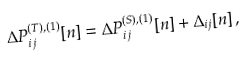<formula> <loc_0><loc_0><loc_500><loc_500>\Delta P _ { i j } ^ { ( T ) , ( 1 ) } [ n ] = \Delta P _ { i j } ^ { ( S ) , ( 1 ) } [ n ] + \Delta _ { i j } [ n ] \, ,</formula> 